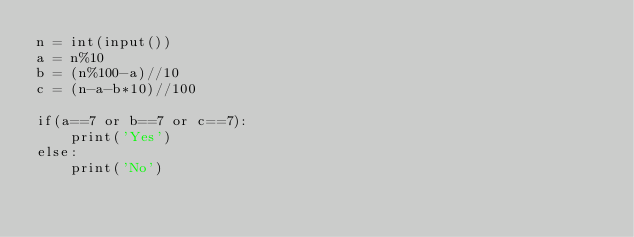<code> <loc_0><loc_0><loc_500><loc_500><_Python_>n = int(input())
a = n%10
b = (n%100-a)//10
c = (n-a-b*10)//100

if(a==7 or b==7 or c==7):
    print('Yes')
else:
    print('No')</code> 